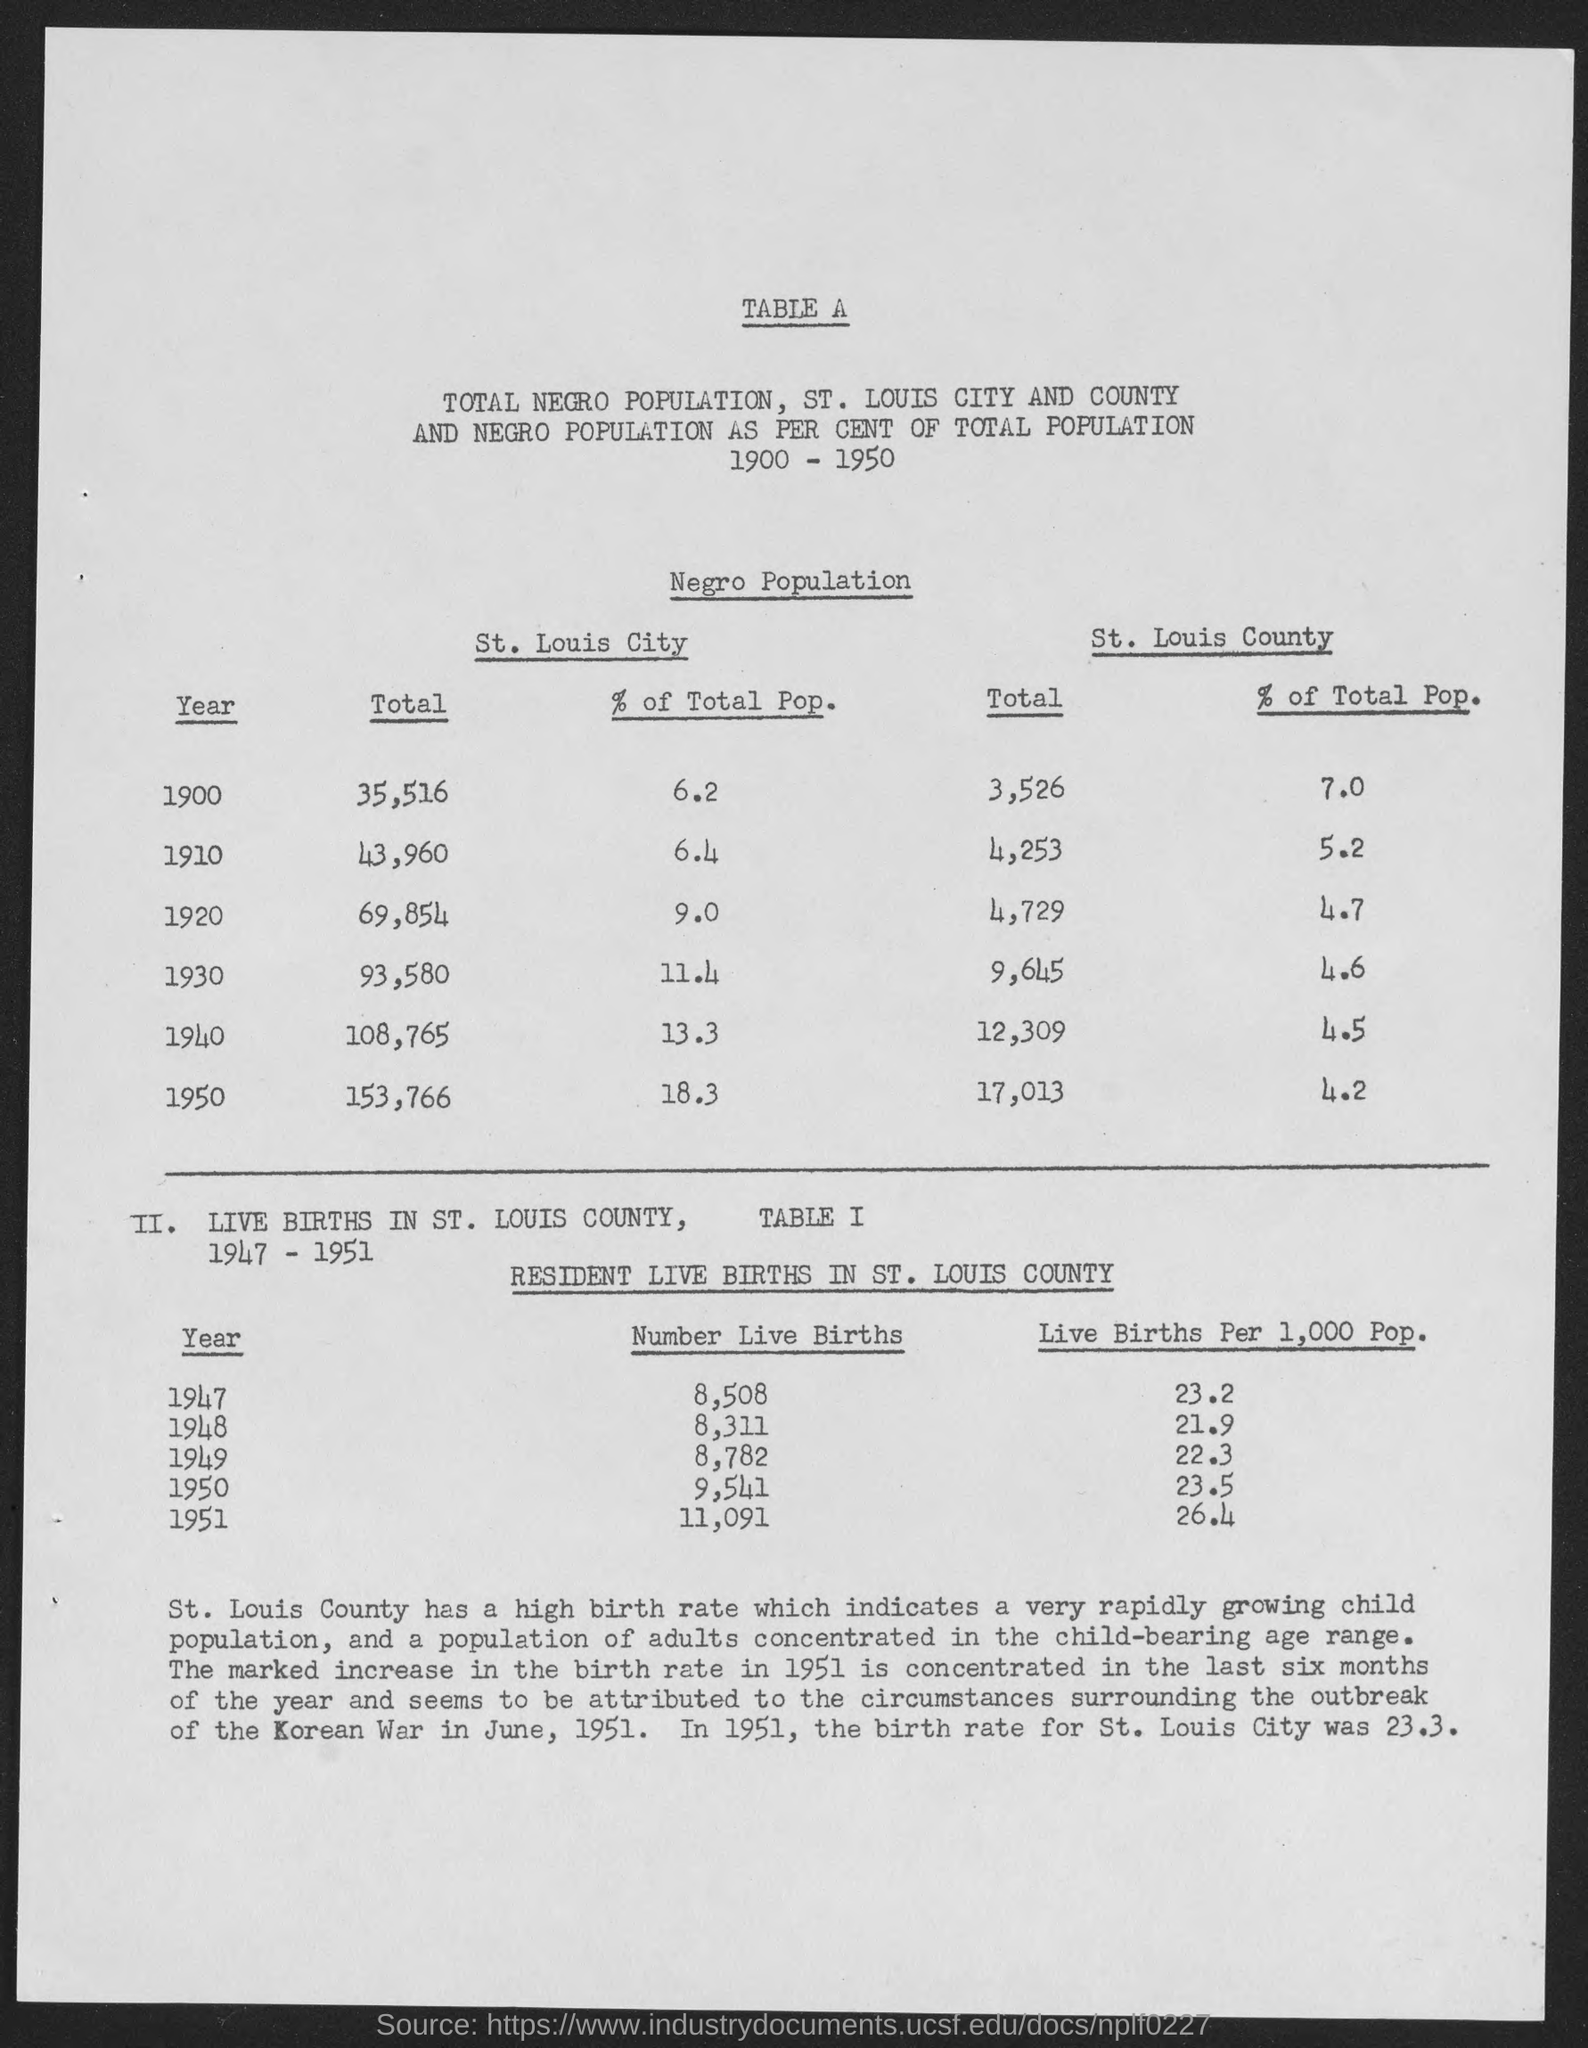Mention a couple of crucial points in this snapshot. The total number of residents in St. Louis City in the year 1950 was 153,766. The total in St. Louis City for the year 1900 was 35,516. The percentage of the total population in St. Louis City for the year 1930 was 11.4%. The total amount for St. Louis City in the year 1940 was 108,765. In the year 1920, approximately 9.0% of the total population in St. Louis City was recorded. 